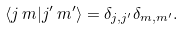Convert formula to latex. <formula><loc_0><loc_0><loc_500><loc_500>\langle j \, m | j ^ { \prime } \, m ^ { \prime } \rangle = \delta _ { j , j ^ { \prime } } \delta _ { m , m ^ { \prime } } .</formula> 